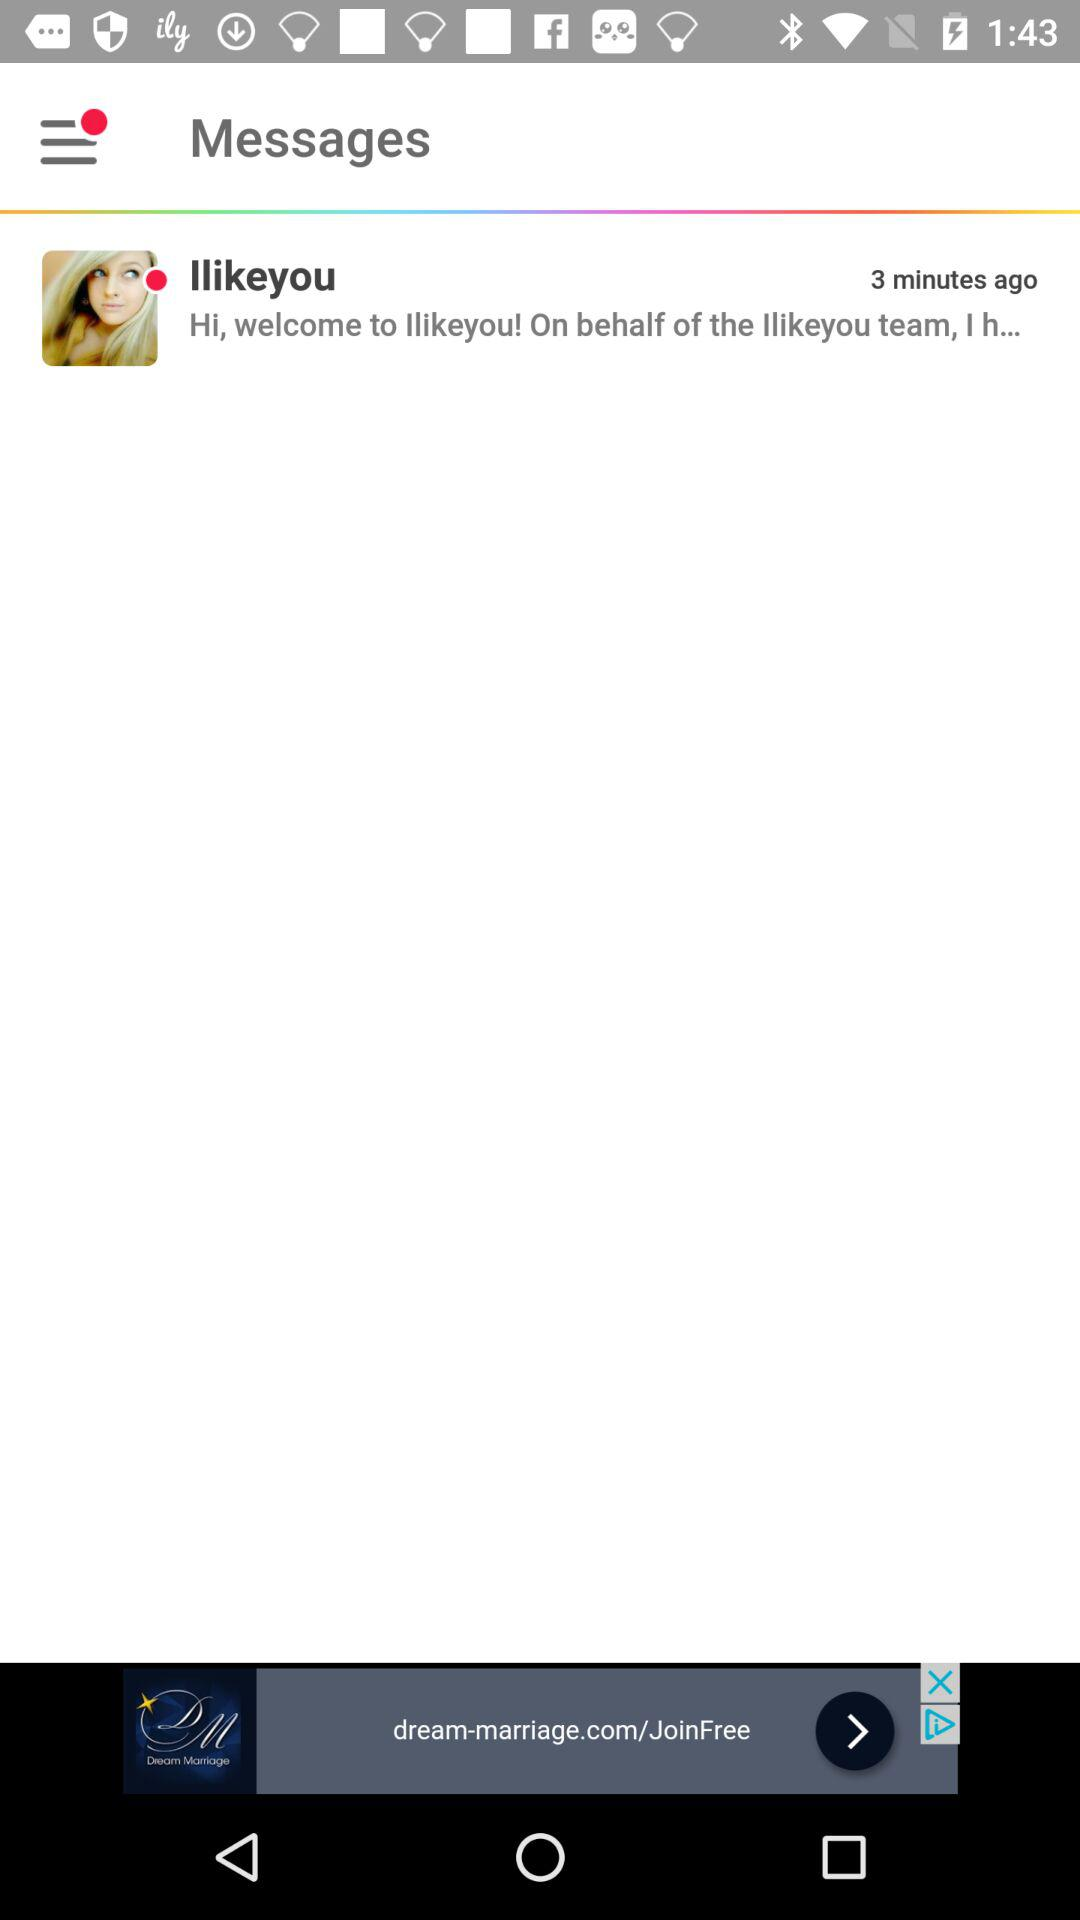How many minutes ago was the message sent?
Answer the question using a single word or phrase. 3 